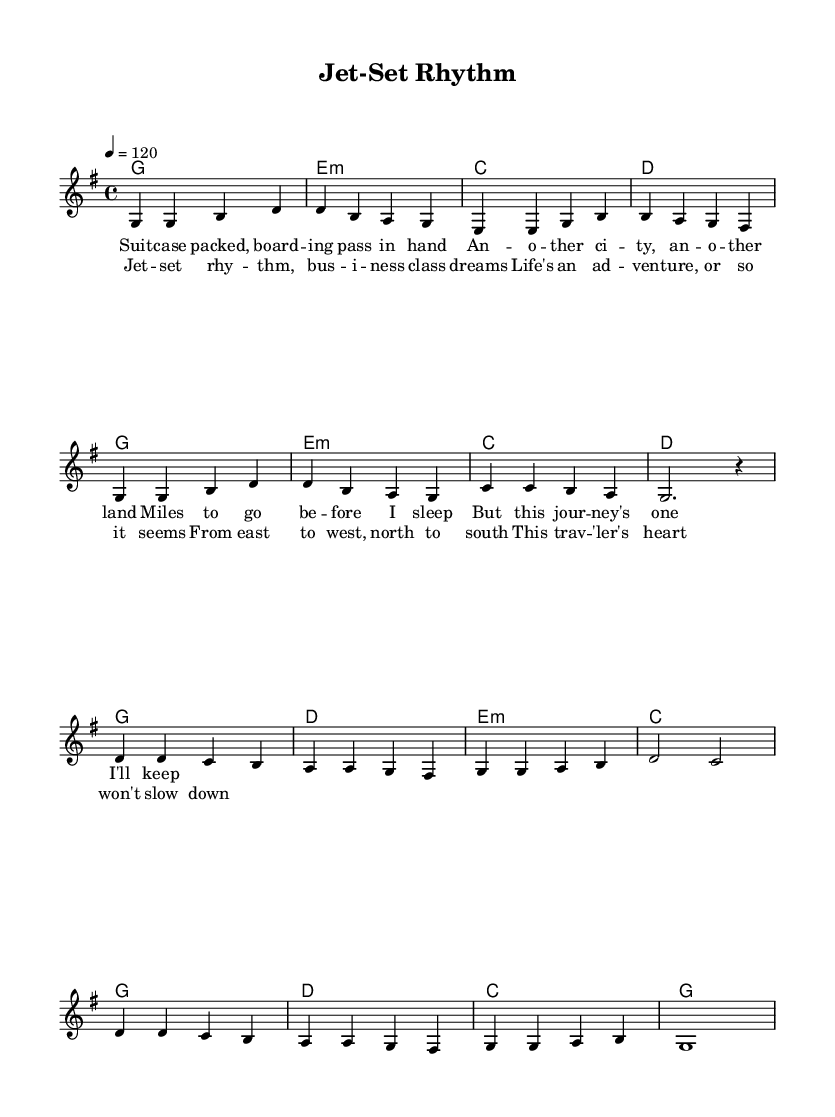What is the key signature of this music? The key signature is G major, which contains one sharp (F#). It can be found at the beginning of the staff at the start of the music.
Answer: G major What is the time signature of this piece? The time signature is 4/4, indicating four beats in each measure, which is represented at the beginning of the first line of the music.
Answer: 4/4 What is the tempo marking for this piece? The tempo marking is 120 beats per minute, shown at the beginning of the score as "4 = 120". This indicates the speed of the music.
Answer: 120 How many measures are in the verse? The verse consists of 8 measures, which can be counted in the melody section as there are 8 distinct rhythmic groups before the transition to the chorus.
Answer: 8 What is the final chord in the chorus? The final chord in the chorus is G major, which is indicated on the last chord in the harmonic section aligned with the last measure of the chorus lyrics.
Answer: G How does the melody of the chorus compare to that of the verse? The melody of the chorus features higher notes than the verse, providing a contrasting lift. By analyzing the ranges of notes, we can see that notes in the chorus reach higher pitches compared to the verse.
Answer: Higher What lyrical theme is presented in this song? The lyrical theme centers around travel and adventure, as indicated by phrases like "This traveler's heart won't slow down" in the chorus, emphasizing a sense of movement and discovery.
Answer: Travel and adventure 